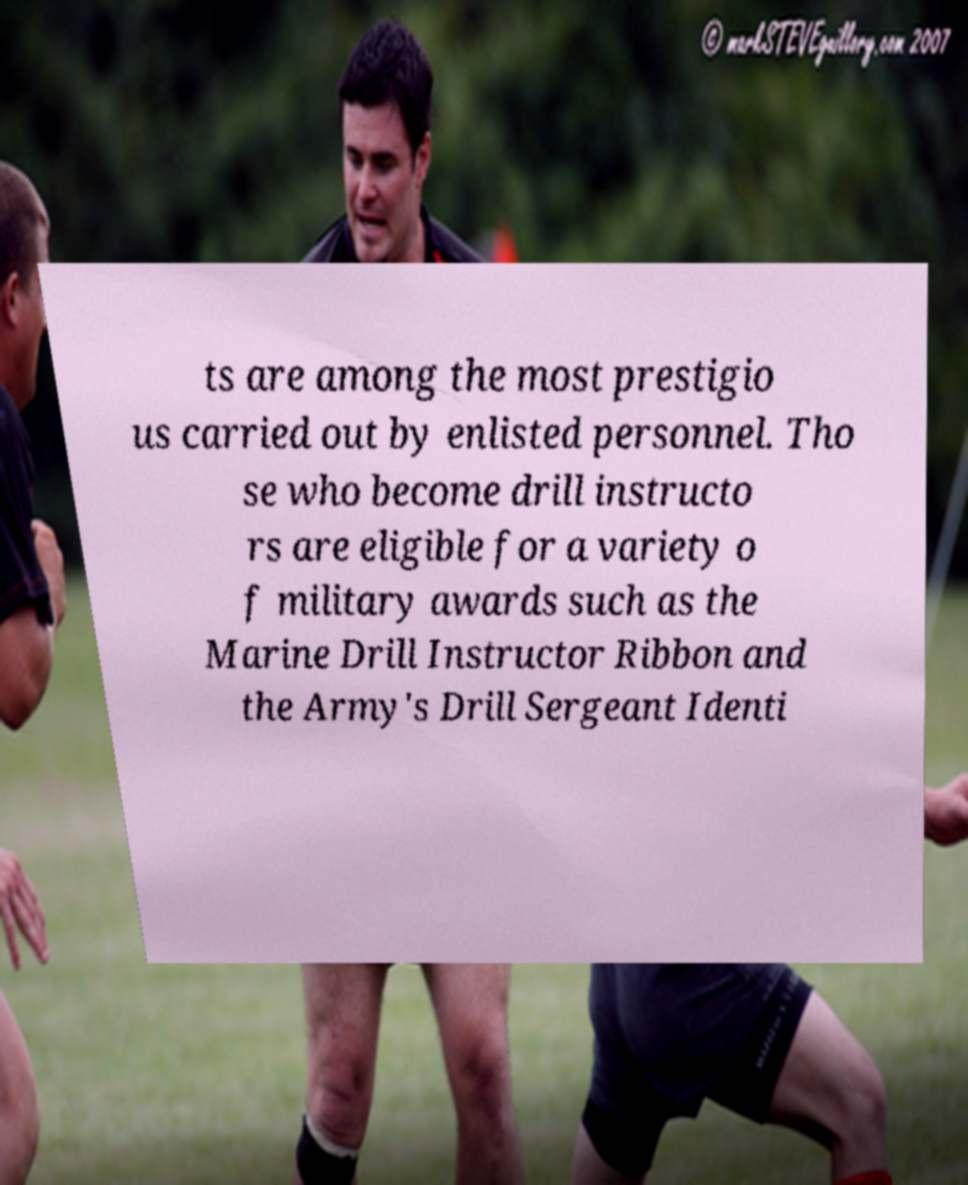I need the written content from this picture converted into text. Can you do that? ts are among the most prestigio us carried out by enlisted personnel. Tho se who become drill instructo rs are eligible for a variety o f military awards such as the Marine Drill Instructor Ribbon and the Army's Drill Sergeant Identi 